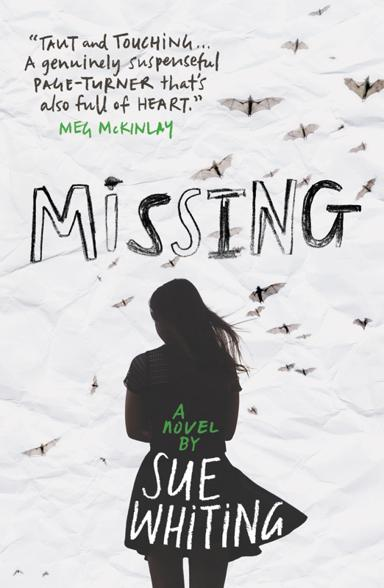Who might be the target audience for this book based on the cover design? The aesthetic and thematic elements of the cover design, which includes a youthful silhouette and an emotive, mysterious ambiance, suggest that 'Missing' by Sue Whiting might primarily appeal to young adult readers. This demographic often gravitates towards stories that explore identity, loss, and personal challenges. The cover implies a narrative that could resonate with readers who appreciate emotional depth, suspense, and character-driven storytelling within the young adult genre. 